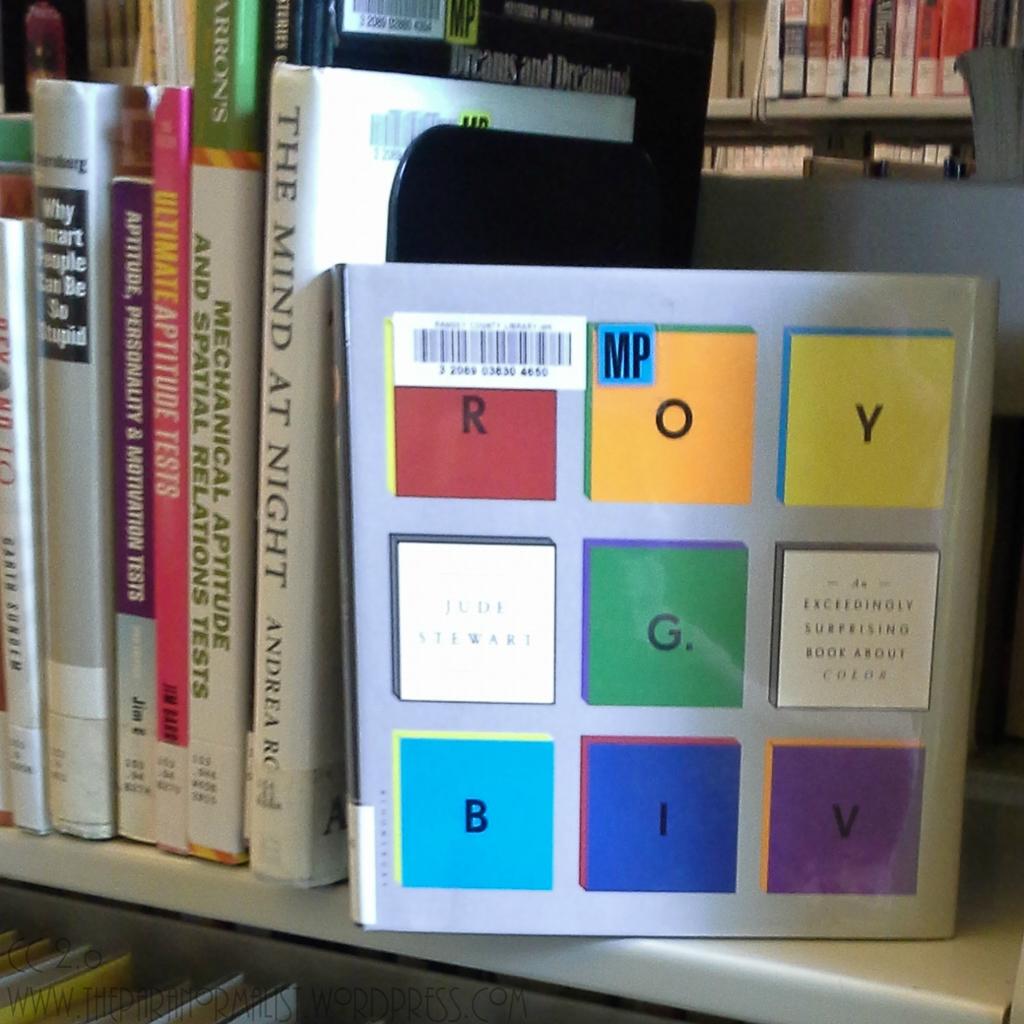What letter is in the purple square on the bottom right?
Make the answer very short. V. 